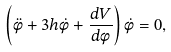<formula> <loc_0><loc_0><loc_500><loc_500>\left ( \ddot { \phi } + 3 h \dot { \phi } + \frac { d V } { d \phi } \right ) \dot { \phi } = 0 ,</formula> 